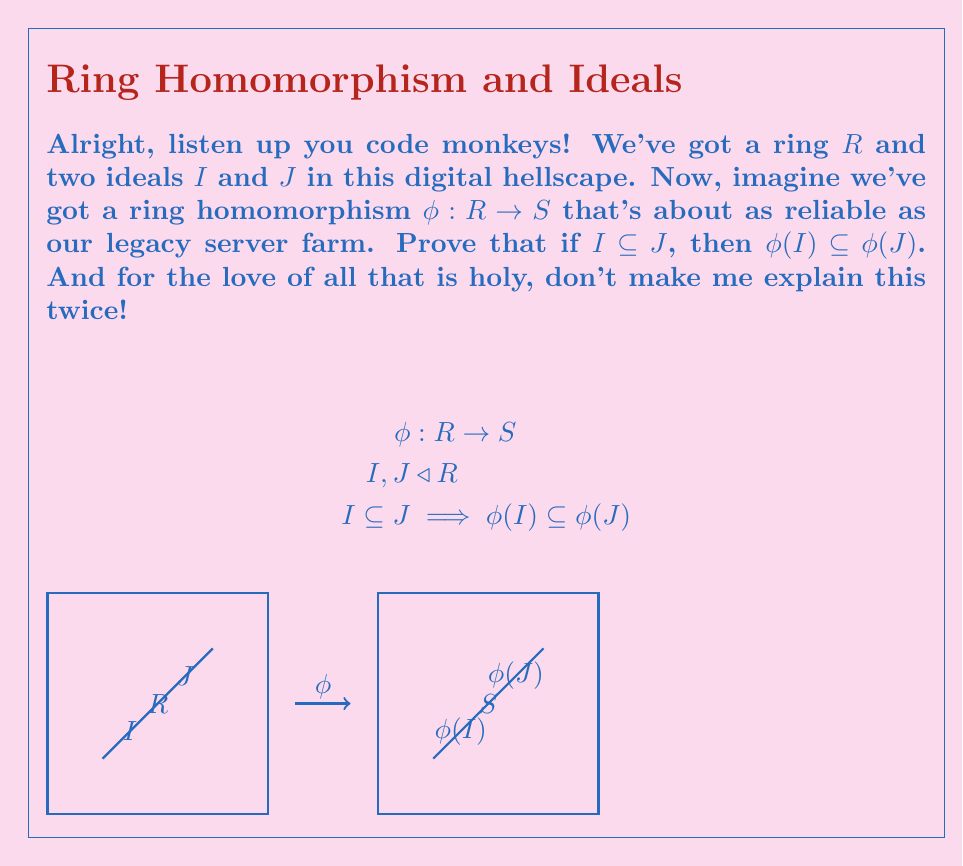What is the answer to this math problem? Alright, you caffeine-addled keyboard jockeys, let's break this down so even the most sleep-deprived among you can follow:

1) First off, we're dealing with a ring homomorphism $\phi: R \rightarrow S$. This bad boy preserves the ring structure, much like how our load balancer preserves the illusion that our system isn't held together with duct tape and prayers.

2) We've got two ideals $I$ and $J$ in $R$, and we're told that $I \subseteq J$. This is like saying all the bugs in our legacy codebase ($I$) are also part of the total technical debt ($J$).

3) Now, we need to prove that $\phi(I) \subseteq \phi(J)$. Buckle up, because this is where it gets as messy as our version control history.

4) Take any element $y \in \phi(I)$. This means there exists some $x \in I$ such that $\phi(x) = y$. Are you following, or do I need to draw you a flowchart?

5) Since $I \subseteq J$, this $x$ we just found is also in $J$. It's like finding a critical bug that's also part of our "won't fix" backlog.

6) Now, here's the kicker: since $x \in J$, and $\phi(x) = y$, we've just shown that $y \in \phi(J)$.

7) We've proven that any arbitrary element $y$ in $\phi(I)$ is also in $\phi(J)$. This is the very definition of subset, you dense datacenters!

8) Therefore, $\phi(I) \subseteq \phi(J)$. QED, mic drop, whatever you want to call it.

And there you have it. If you didn't follow that, I swear I'll make you debug our entire codebase with nothing but print statements and a rusty spoon.
Answer: $\phi(I) \subseteq \phi(J)$ 